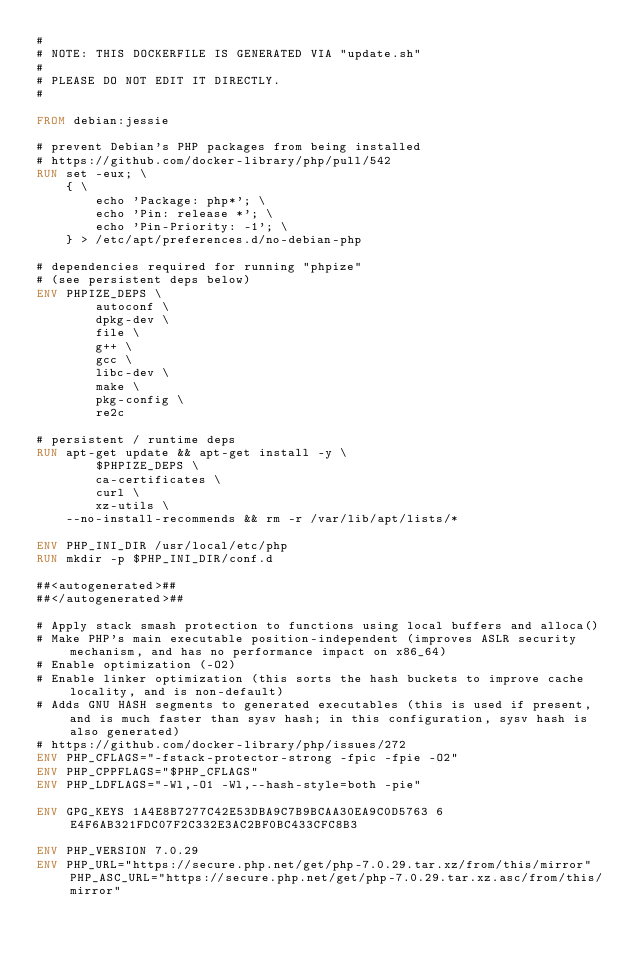Convert code to text. <code><loc_0><loc_0><loc_500><loc_500><_Dockerfile_>#
# NOTE: THIS DOCKERFILE IS GENERATED VIA "update.sh"
#
# PLEASE DO NOT EDIT IT DIRECTLY.
#

FROM debian:jessie

# prevent Debian's PHP packages from being installed
# https://github.com/docker-library/php/pull/542
RUN set -eux; \
	{ \
		echo 'Package: php*'; \
		echo 'Pin: release *'; \
		echo 'Pin-Priority: -1'; \
	} > /etc/apt/preferences.d/no-debian-php

# dependencies required for running "phpize"
# (see persistent deps below)
ENV PHPIZE_DEPS \
		autoconf \
		dpkg-dev \
		file \
		g++ \
		gcc \
		libc-dev \
		make \
		pkg-config \
		re2c

# persistent / runtime deps
RUN apt-get update && apt-get install -y \
		$PHPIZE_DEPS \
		ca-certificates \
		curl \
		xz-utils \
	--no-install-recommends && rm -r /var/lib/apt/lists/*

ENV PHP_INI_DIR /usr/local/etc/php
RUN mkdir -p $PHP_INI_DIR/conf.d

##<autogenerated>##
##</autogenerated>##

# Apply stack smash protection to functions using local buffers and alloca()
# Make PHP's main executable position-independent (improves ASLR security mechanism, and has no performance impact on x86_64)
# Enable optimization (-O2)
# Enable linker optimization (this sorts the hash buckets to improve cache locality, and is non-default)
# Adds GNU HASH segments to generated executables (this is used if present, and is much faster than sysv hash; in this configuration, sysv hash is also generated)
# https://github.com/docker-library/php/issues/272
ENV PHP_CFLAGS="-fstack-protector-strong -fpic -fpie -O2"
ENV PHP_CPPFLAGS="$PHP_CFLAGS"
ENV PHP_LDFLAGS="-Wl,-O1 -Wl,--hash-style=both -pie"

ENV GPG_KEYS 1A4E8B7277C42E53DBA9C7B9BCAA30EA9C0D5763 6E4F6AB321FDC07F2C332E3AC2BF0BC433CFC8B3

ENV PHP_VERSION 7.0.29
ENV PHP_URL="https://secure.php.net/get/php-7.0.29.tar.xz/from/this/mirror" PHP_ASC_URL="https://secure.php.net/get/php-7.0.29.tar.xz.asc/from/this/mirror"</code> 